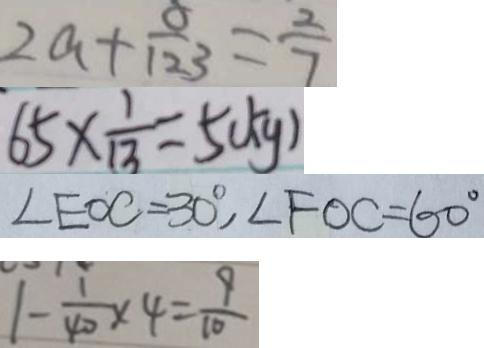Convert formula to latex. <formula><loc_0><loc_0><loc_500><loc_500>2 a + \frac { 8 } { 1 2 3 } = \frac { 2 } { 7 } 
 6 5 \times \frac { 1 } { 1 3 } = 5 ( k g ) 
 \angle E O C = 3 0 ^ { \circ } , \angle F O C = 6 0 ^ { \circ } 
 1 - \frac { 1 } { 4 0 } \times 4 = \frac { 9 } { 1 0 }</formula> 